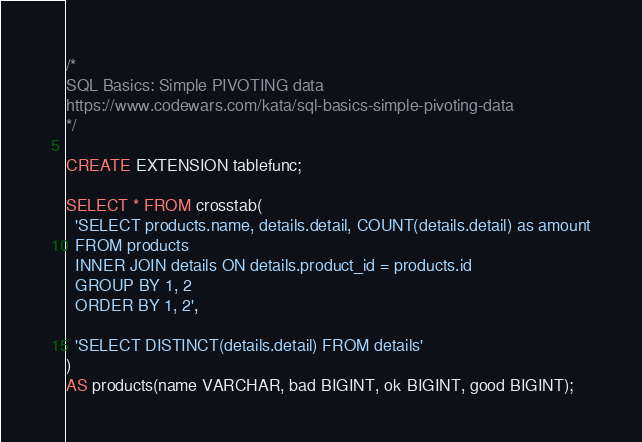Convert code to text. <code><loc_0><loc_0><loc_500><loc_500><_SQL_>/*
SQL Basics: Simple PIVOTING data
https://www.codewars.com/kata/sql-basics-simple-pivoting-data
*/

CREATE EXTENSION tablefunc;

SELECT * FROM crosstab(
  'SELECT products.name, details.detail, COUNT(details.detail) as amount
  FROM products
  INNER JOIN details ON details.product_id = products.id
  GROUP BY 1, 2
  ORDER BY 1, 2',

  'SELECT DISTINCT(details.detail) FROM details'
)
AS products(name VARCHAR, bad BIGINT, ok BIGINT, good BIGINT);
</code> 